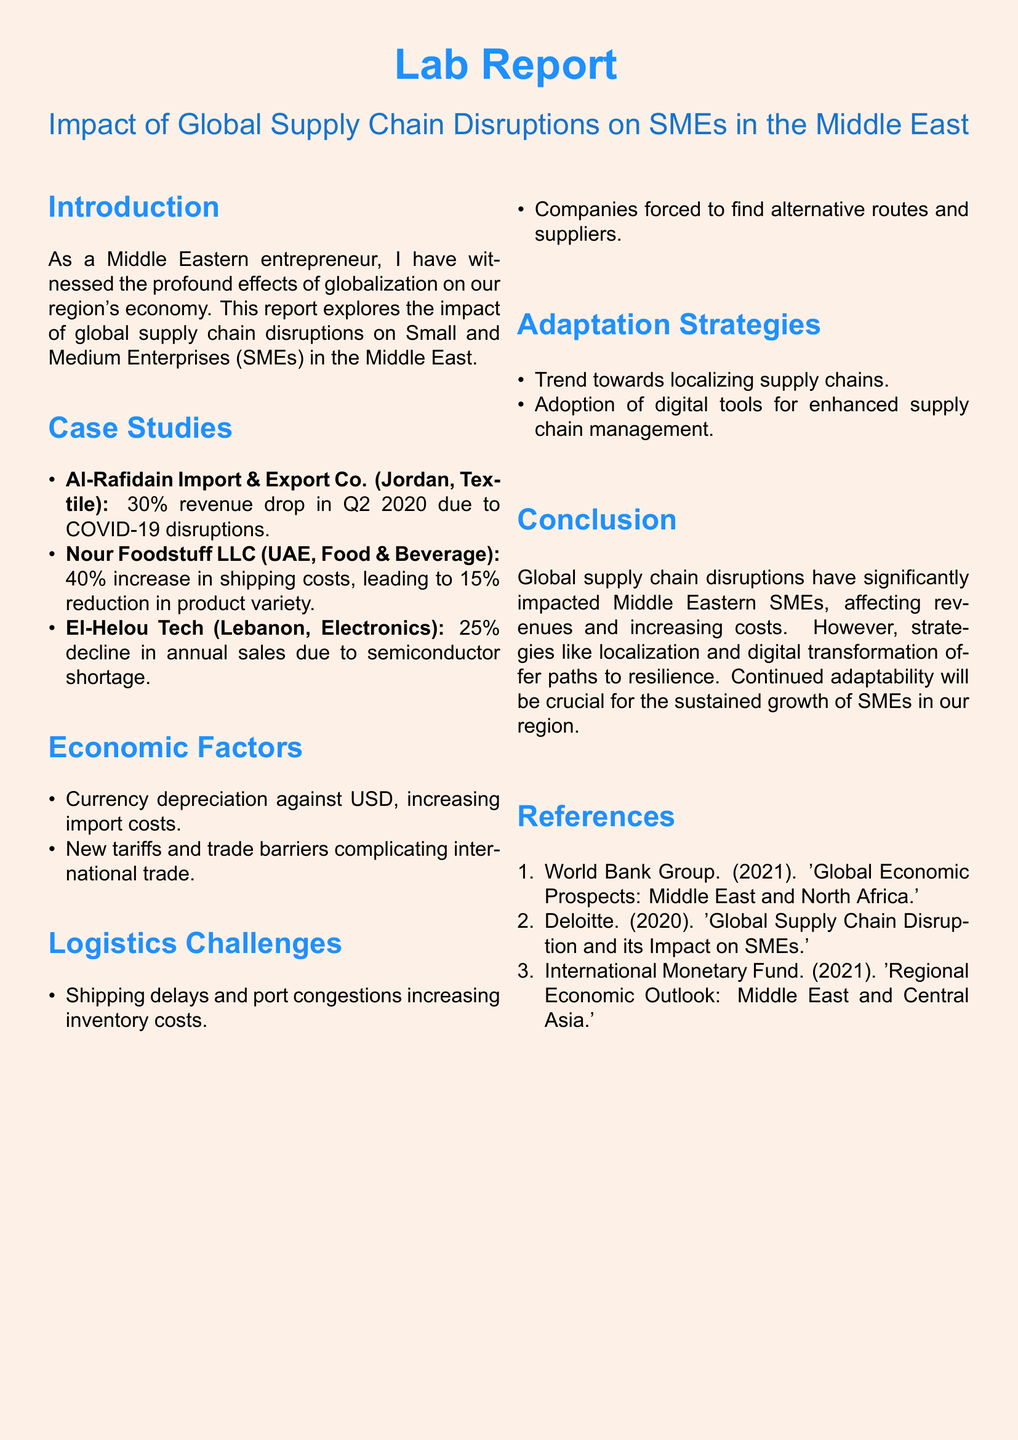What was the revenue drop for Al-Rafidain Import & Export Co.? The report states a revenue drop of 30% for the company in Q2 2020 due to COVID-19 disruptions.
Answer: 30% What is the primary impact of increased shipping costs on Nour Foodstuff LLC? The document explains that the increase in shipping costs led to a 15% reduction in product variety for Nour Foodstuff LLC.
Answer: 15% Which country is El-Helou Tech based in? The report identifies El-Helou Tech as a company based in Lebanon.
Answer: Lebanon What adaptation strategy involves enhancing supply chain management? The report indicates that the adoption of digital tools is a strategy for enhanced supply chain management.
Answer: Digital tools What economic factor is mentioned that complicates international trade? The report refers to new tariffs as an economic factor complicating international trade.
Answer: New tariffs What percentage decline in annual sales did El-Helou Tech experience? The document states that El-Helou Tech experienced a 25% decline in annual sales due to semiconductor shortage.
Answer: 25% What is a trend observed in supply chain strategies according to the report? The lab report highlights a trend towards localizing supply chains as an adaptation strategy.
Answer: Localizing supply chains How did currency depreciation affect import costs? The document notes that currency depreciation against USD resulted in increasing import costs.
Answer: Increasing import costs 